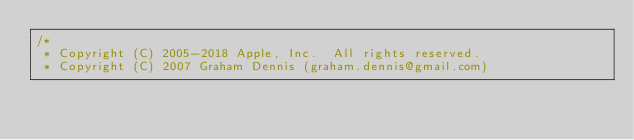Convert code to text. <code><loc_0><loc_0><loc_500><loc_500><_ObjectiveC_>/*
 * Copyright (C) 2005-2018 Apple, Inc.  All rights reserved.
 * Copyright (C) 2007 Graham Dennis (graham.dennis@gmail.com)</code> 